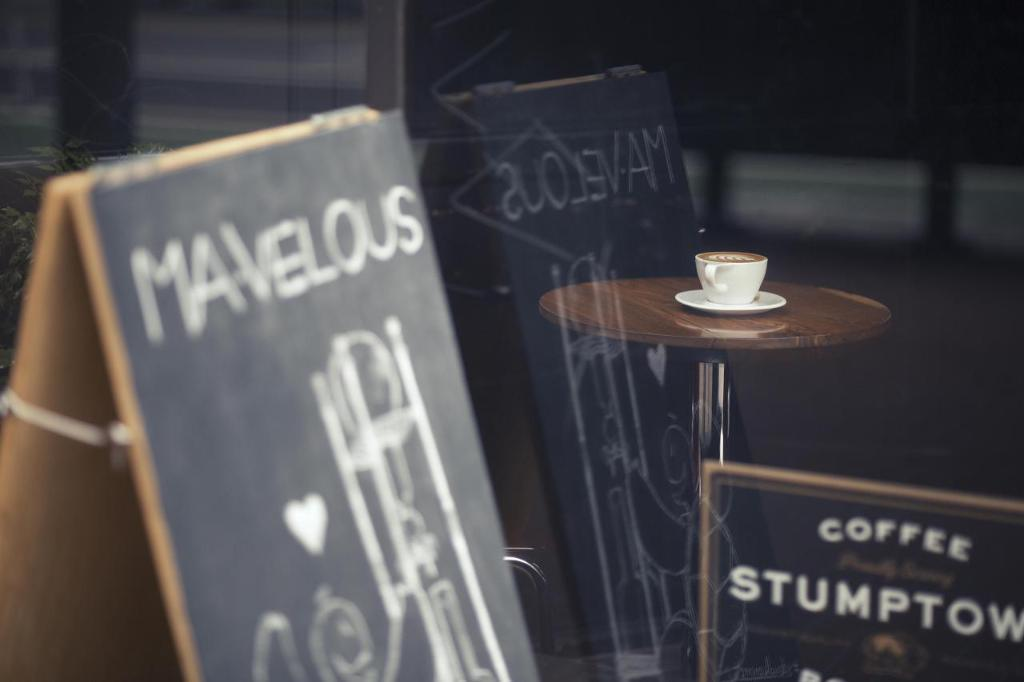What object is placed on the table in the image? There is a cup on a table in the image. What other object can be seen in the image besides the cup? There is a board in the image. How much dirt is visible on the board in the image? There is no dirt visible on the board in the image, as the facts provided do not mention dirt. 